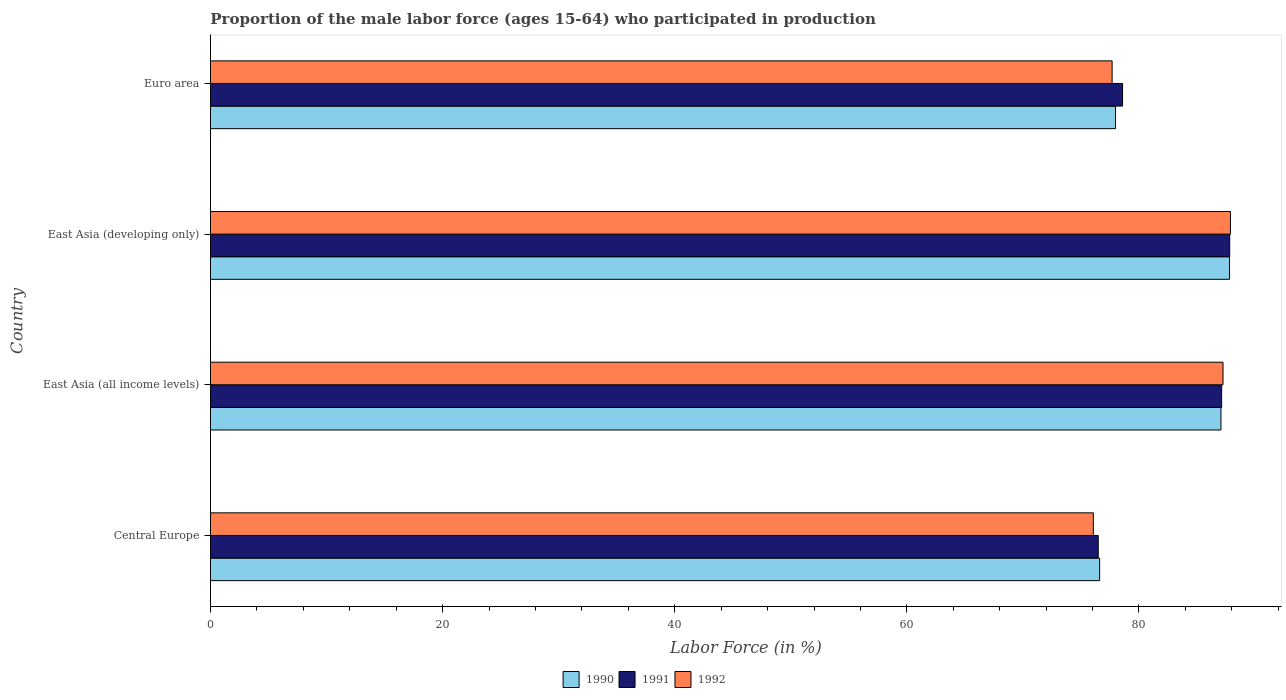How many different coloured bars are there?
Your answer should be compact. 3. How many groups of bars are there?
Your response must be concise. 4. Are the number of bars on each tick of the Y-axis equal?
Keep it short and to the point. Yes. What is the label of the 2nd group of bars from the top?
Keep it short and to the point. East Asia (developing only). In how many cases, is the number of bars for a given country not equal to the number of legend labels?
Offer a terse response. 0. What is the proportion of the male labor force who participated in production in 1990 in Euro area?
Provide a short and direct response. 77.98. Across all countries, what is the maximum proportion of the male labor force who participated in production in 1990?
Your response must be concise. 87.8. Across all countries, what is the minimum proportion of the male labor force who participated in production in 1990?
Give a very brief answer. 76.61. In which country was the proportion of the male labor force who participated in production in 1992 maximum?
Your answer should be compact. East Asia (developing only). In which country was the proportion of the male labor force who participated in production in 1992 minimum?
Give a very brief answer. Central Europe. What is the total proportion of the male labor force who participated in production in 1990 in the graph?
Give a very brief answer. 329.46. What is the difference between the proportion of the male labor force who participated in production in 1990 in Central Europe and that in East Asia (all income levels)?
Your response must be concise. -10.45. What is the difference between the proportion of the male labor force who participated in production in 1990 in Central Europe and the proportion of the male labor force who participated in production in 1992 in East Asia (developing only)?
Give a very brief answer. -11.27. What is the average proportion of the male labor force who participated in production in 1990 per country?
Provide a short and direct response. 82.36. What is the difference between the proportion of the male labor force who participated in production in 1992 and proportion of the male labor force who participated in production in 1991 in Euro area?
Provide a short and direct response. -0.9. What is the ratio of the proportion of the male labor force who participated in production in 1990 in Central Europe to that in Euro area?
Your answer should be compact. 0.98. What is the difference between the highest and the second highest proportion of the male labor force who participated in production in 1992?
Your answer should be very brief. 0.64. What is the difference between the highest and the lowest proportion of the male labor force who participated in production in 1992?
Keep it short and to the point. 11.82. What does the 2nd bar from the bottom in Euro area represents?
Make the answer very short. 1991. Is it the case that in every country, the sum of the proportion of the male labor force who participated in production in 1992 and proportion of the male labor force who participated in production in 1990 is greater than the proportion of the male labor force who participated in production in 1991?
Give a very brief answer. Yes. How many bars are there?
Provide a short and direct response. 12. Are the values on the major ticks of X-axis written in scientific E-notation?
Provide a succinct answer. No. Does the graph contain any zero values?
Ensure brevity in your answer.  No. Does the graph contain grids?
Ensure brevity in your answer.  No. Where does the legend appear in the graph?
Your answer should be very brief. Bottom center. What is the title of the graph?
Your response must be concise. Proportion of the male labor force (ages 15-64) who participated in production. What is the Labor Force (in %) of 1990 in Central Europe?
Offer a very short reply. 76.61. What is the Labor Force (in %) in 1991 in Central Europe?
Make the answer very short. 76.49. What is the Labor Force (in %) in 1992 in Central Europe?
Provide a short and direct response. 76.07. What is the Labor Force (in %) of 1990 in East Asia (all income levels)?
Provide a succinct answer. 87.06. What is the Labor Force (in %) in 1991 in East Asia (all income levels)?
Offer a very short reply. 87.12. What is the Labor Force (in %) of 1992 in East Asia (all income levels)?
Keep it short and to the point. 87.24. What is the Labor Force (in %) in 1990 in East Asia (developing only)?
Ensure brevity in your answer.  87.8. What is the Labor Force (in %) of 1991 in East Asia (developing only)?
Provide a short and direct response. 87.82. What is the Labor Force (in %) in 1992 in East Asia (developing only)?
Your answer should be compact. 87.89. What is the Labor Force (in %) in 1990 in Euro area?
Provide a succinct answer. 77.98. What is the Labor Force (in %) in 1991 in Euro area?
Your answer should be very brief. 78.59. What is the Labor Force (in %) in 1992 in Euro area?
Keep it short and to the point. 77.69. Across all countries, what is the maximum Labor Force (in %) in 1990?
Your answer should be compact. 87.8. Across all countries, what is the maximum Labor Force (in %) of 1991?
Keep it short and to the point. 87.82. Across all countries, what is the maximum Labor Force (in %) of 1992?
Provide a succinct answer. 87.89. Across all countries, what is the minimum Labor Force (in %) of 1990?
Give a very brief answer. 76.61. Across all countries, what is the minimum Labor Force (in %) of 1991?
Offer a very short reply. 76.49. Across all countries, what is the minimum Labor Force (in %) in 1992?
Give a very brief answer. 76.07. What is the total Labor Force (in %) of 1990 in the graph?
Ensure brevity in your answer.  329.46. What is the total Labor Force (in %) in 1991 in the graph?
Provide a succinct answer. 330.02. What is the total Labor Force (in %) of 1992 in the graph?
Ensure brevity in your answer.  328.88. What is the difference between the Labor Force (in %) in 1990 in Central Europe and that in East Asia (all income levels)?
Your response must be concise. -10.45. What is the difference between the Labor Force (in %) of 1991 in Central Europe and that in East Asia (all income levels)?
Give a very brief answer. -10.63. What is the difference between the Labor Force (in %) of 1992 in Central Europe and that in East Asia (all income levels)?
Keep it short and to the point. -11.17. What is the difference between the Labor Force (in %) of 1990 in Central Europe and that in East Asia (developing only)?
Give a very brief answer. -11.19. What is the difference between the Labor Force (in %) in 1991 in Central Europe and that in East Asia (developing only)?
Ensure brevity in your answer.  -11.33. What is the difference between the Labor Force (in %) in 1992 in Central Europe and that in East Asia (developing only)?
Provide a succinct answer. -11.82. What is the difference between the Labor Force (in %) of 1990 in Central Europe and that in Euro area?
Your answer should be compact. -1.37. What is the difference between the Labor Force (in %) in 1991 in Central Europe and that in Euro area?
Provide a short and direct response. -2.1. What is the difference between the Labor Force (in %) in 1992 in Central Europe and that in Euro area?
Your answer should be very brief. -1.62. What is the difference between the Labor Force (in %) in 1990 in East Asia (all income levels) and that in East Asia (developing only)?
Your answer should be compact. -0.74. What is the difference between the Labor Force (in %) in 1991 in East Asia (all income levels) and that in East Asia (developing only)?
Your response must be concise. -0.69. What is the difference between the Labor Force (in %) in 1992 in East Asia (all income levels) and that in East Asia (developing only)?
Your answer should be compact. -0.64. What is the difference between the Labor Force (in %) of 1990 in East Asia (all income levels) and that in Euro area?
Offer a very short reply. 9.08. What is the difference between the Labor Force (in %) of 1991 in East Asia (all income levels) and that in Euro area?
Provide a succinct answer. 8.54. What is the difference between the Labor Force (in %) in 1992 in East Asia (all income levels) and that in Euro area?
Provide a short and direct response. 9.56. What is the difference between the Labor Force (in %) of 1990 in East Asia (developing only) and that in Euro area?
Your response must be concise. 9.82. What is the difference between the Labor Force (in %) in 1991 in East Asia (developing only) and that in Euro area?
Provide a succinct answer. 9.23. What is the difference between the Labor Force (in %) in 1992 in East Asia (developing only) and that in Euro area?
Your response must be concise. 10.2. What is the difference between the Labor Force (in %) of 1990 in Central Europe and the Labor Force (in %) of 1991 in East Asia (all income levels)?
Provide a short and direct response. -10.51. What is the difference between the Labor Force (in %) of 1990 in Central Europe and the Labor Force (in %) of 1992 in East Asia (all income levels)?
Keep it short and to the point. -10.63. What is the difference between the Labor Force (in %) of 1991 in Central Europe and the Labor Force (in %) of 1992 in East Asia (all income levels)?
Give a very brief answer. -10.75. What is the difference between the Labor Force (in %) in 1990 in Central Europe and the Labor Force (in %) in 1991 in East Asia (developing only)?
Your answer should be very brief. -11.21. What is the difference between the Labor Force (in %) in 1990 in Central Europe and the Labor Force (in %) in 1992 in East Asia (developing only)?
Provide a succinct answer. -11.27. What is the difference between the Labor Force (in %) of 1991 in Central Europe and the Labor Force (in %) of 1992 in East Asia (developing only)?
Keep it short and to the point. -11.4. What is the difference between the Labor Force (in %) of 1990 in Central Europe and the Labor Force (in %) of 1991 in Euro area?
Offer a very short reply. -1.98. What is the difference between the Labor Force (in %) in 1990 in Central Europe and the Labor Force (in %) in 1992 in Euro area?
Your response must be concise. -1.07. What is the difference between the Labor Force (in %) of 1991 in Central Europe and the Labor Force (in %) of 1992 in Euro area?
Provide a succinct answer. -1.2. What is the difference between the Labor Force (in %) of 1990 in East Asia (all income levels) and the Labor Force (in %) of 1991 in East Asia (developing only)?
Keep it short and to the point. -0.75. What is the difference between the Labor Force (in %) of 1990 in East Asia (all income levels) and the Labor Force (in %) of 1992 in East Asia (developing only)?
Your answer should be very brief. -0.82. What is the difference between the Labor Force (in %) of 1991 in East Asia (all income levels) and the Labor Force (in %) of 1992 in East Asia (developing only)?
Provide a short and direct response. -0.76. What is the difference between the Labor Force (in %) in 1990 in East Asia (all income levels) and the Labor Force (in %) in 1991 in Euro area?
Make the answer very short. 8.48. What is the difference between the Labor Force (in %) in 1990 in East Asia (all income levels) and the Labor Force (in %) in 1992 in Euro area?
Offer a terse response. 9.38. What is the difference between the Labor Force (in %) in 1991 in East Asia (all income levels) and the Labor Force (in %) in 1992 in Euro area?
Your answer should be compact. 9.44. What is the difference between the Labor Force (in %) of 1990 in East Asia (developing only) and the Labor Force (in %) of 1991 in Euro area?
Provide a succinct answer. 9.22. What is the difference between the Labor Force (in %) of 1990 in East Asia (developing only) and the Labor Force (in %) of 1992 in Euro area?
Ensure brevity in your answer.  10.12. What is the difference between the Labor Force (in %) of 1991 in East Asia (developing only) and the Labor Force (in %) of 1992 in Euro area?
Ensure brevity in your answer.  10.13. What is the average Labor Force (in %) in 1990 per country?
Keep it short and to the point. 82.36. What is the average Labor Force (in %) of 1991 per country?
Your response must be concise. 82.5. What is the average Labor Force (in %) of 1992 per country?
Provide a succinct answer. 82.22. What is the difference between the Labor Force (in %) of 1990 and Labor Force (in %) of 1991 in Central Europe?
Make the answer very short. 0.12. What is the difference between the Labor Force (in %) in 1990 and Labor Force (in %) in 1992 in Central Europe?
Offer a terse response. 0.54. What is the difference between the Labor Force (in %) of 1991 and Labor Force (in %) of 1992 in Central Europe?
Offer a terse response. 0.42. What is the difference between the Labor Force (in %) in 1990 and Labor Force (in %) in 1991 in East Asia (all income levels)?
Provide a short and direct response. -0.06. What is the difference between the Labor Force (in %) in 1990 and Labor Force (in %) in 1992 in East Asia (all income levels)?
Your answer should be compact. -0.18. What is the difference between the Labor Force (in %) in 1991 and Labor Force (in %) in 1992 in East Asia (all income levels)?
Offer a terse response. -0.12. What is the difference between the Labor Force (in %) of 1990 and Labor Force (in %) of 1991 in East Asia (developing only)?
Keep it short and to the point. -0.01. What is the difference between the Labor Force (in %) of 1990 and Labor Force (in %) of 1992 in East Asia (developing only)?
Offer a terse response. -0.08. What is the difference between the Labor Force (in %) of 1991 and Labor Force (in %) of 1992 in East Asia (developing only)?
Make the answer very short. -0.07. What is the difference between the Labor Force (in %) of 1990 and Labor Force (in %) of 1991 in Euro area?
Keep it short and to the point. -0.61. What is the difference between the Labor Force (in %) in 1990 and Labor Force (in %) in 1992 in Euro area?
Offer a terse response. 0.29. What is the difference between the Labor Force (in %) in 1991 and Labor Force (in %) in 1992 in Euro area?
Your answer should be compact. 0.9. What is the ratio of the Labor Force (in %) of 1991 in Central Europe to that in East Asia (all income levels)?
Make the answer very short. 0.88. What is the ratio of the Labor Force (in %) of 1992 in Central Europe to that in East Asia (all income levels)?
Offer a terse response. 0.87. What is the ratio of the Labor Force (in %) of 1990 in Central Europe to that in East Asia (developing only)?
Your answer should be compact. 0.87. What is the ratio of the Labor Force (in %) of 1991 in Central Europe to that in East Asia (developing only)?
Your answer should be very brief. 0.87. What is the ratio of the Labor Force (in %) of 1992 in Central Europe to that in East Asia (developing only)?
Your response must be concise. 0.87. What is the ratio of the Labor Force (in %) of 1990 in Central Europe to that in Euro area?
Provide a succinct answer. 0.98. What is the ratio of the Labor Force (in %) of 1991 in Central Europe to that in Euro area?
Provide a short and direct response. 0.97. What is the ratio of the Labor Force (in %) of 1992 in Central Europe to that in Euro area?
Offer a very short reply. 0.98. What is the ratio of the Labor Force (in %) in 1992 in East Asia (all income levels) to that in East Asia (developing only)?
Offer a very short reply. 0.99. What is the ratio of the Labor Force (in %) in 1990 in East Asia (all income levels) to that in Euro area?
Offer a very short reply. 1.12. What is the ratio of the Labor Force (in %) in 1991 in East Asia (all income levels) to that in Euro area?
Provide a succinct answer. 1.11. What is the ratio of the Labor Force (in %) in 1992 in East Asia (all income levels) to that in Euro area?
Provide a short and direct response. 1.12. What is the ratio of the Labor Force (in %) in 1990 in East Asia (developing only) to that in Euro area?
Provide a short and direct response. 1.13. What is the ratio of the Labor Force (in %) of 1991 in East Asia (developing only) to that in Euro area?
Provide a succinct answer. 1.12. What is the ratio of the Labor Force (in %) of 1992 in East Asia (developing only) to that in Euro area?
Your response must be concise. 1.13. What is the difference between the highest and the second highest Labor Force (in %) of 1990?
Your answer should be very brief. 0.74. What is the difference between the highest and the second highest Labor Force (in %) in 1991?
Your answer should be compact. 0.69. What is the difference between the highest and the second highest Labor Force (in %) of 1992?
Your answer should be very brief. 0.64. What is the difference between the highest and the lowest Labor Force (in %) of 1990?
Give a very brief answer. 11.19. What is the difference between the highest and the lowest Labor Force (in %) of 1991?
Ensure brevity in your answer.  11.33. What is the difference between the highest and the lowest Labor Force (in %) of 1992?
Offer a terse response. 11.82. 